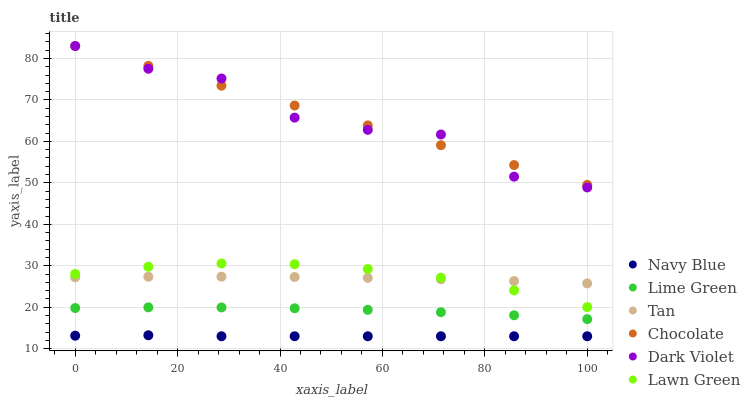Does Navy Blue have the minimum area under the curve?
Answer yes or no. Yes. Does Chocolate have the maximum area under the curve?
Answer yes or no. Yes. Does Dark Violet have the minimum area under the curve?
Answer yes or no. No. Does Dark Violet have the maximum area under the curve?
Answer yes or no. No. Is Chocolate the smoothest?
Answer yes or no. Yes. Is Dark Violet the roughest?
Answer yes or no. Yes. Is Navy Blue the smoothest?
Answer yes or no. No. Is Navy Blue the roughest?
Answer yes or no. No. Does Navy Blue have the lowest value?
Answer yes or no. Yes. Does Dark Violet have the lowest value?
Answer yes or no. No. Does Chocolate have the highest value?
Answer yes or no. Yes. Does Navy Blue have the highest value?
Answer yes or no. No. Is Tan less than Dark Violet?
Answer yes or no. Yes. Is Dark Violet greater than Tan?
Answer yes or no. Yes. Does Lawn Green intersect Tan?
Answer yes or no. Yes. Is Lawn Green less than Tan?
Answer yes or no. No. Is Lawn Green greater than Tan?
Answer yes or no. No. Does Tan intersect Dark Violet?
Answer yes or no. No. 